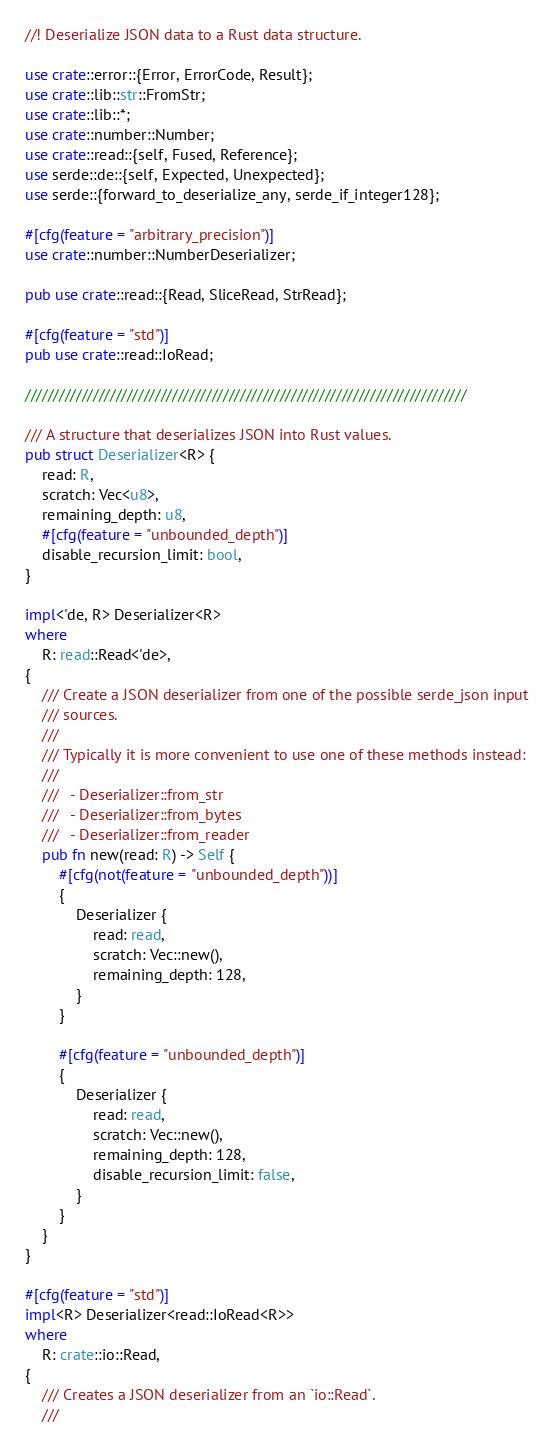<code> <loc_0><loc_0><loc_500><loc_500><_Rust_>//! Deserialize JSON data to a Rust data structure.

use crate::error::{Error, ErrorCode, Result};
use crate::lib::str::FromStr;
use crate::lib::*;
use crate::number::Number;
use crate::read::{self, Fused, Reference};
use serde::de::{self, Expected, Unexpected};
use serde::{forward_to_deserialize_any, serde_if_integer128};

#[cfg(feature = "arbitrary_precision")]
use crate::number::NumberDeserializer;

pub use crate::read::{Read, SliceRead, StrRead};

#[cfg(feature = "std")]
pub use crate::read::IoRead;

//////////////////////////////////////////////////////////////////////////////

/// A structure that deserializes JSON into Rust values.
pub struct Deserializer<R> {
    read: R,
    scratch: Vec<u8>,
    remaining_depth: u8,
    #[cfg(feature = "unbounded_depth")]
    disable_recursion_limit: bool,
}

impl<'de, R> Deserializer<R>
where
    R: read::Read<'de>,
{
    /// Create a JSON deserializer from one of the possible serde_json input
    /// sources.
    ///
    /// Typically it is more convenient to use one of these methods instead:
    ///
    ///   - Deserializer::from_str
    ///   - Deserializer::from_bytes
    ///   - Deserializer::from_reader
    pub fn new(read: R) -> Self {
        #[cfg(not(feature = "unbounded_depth"))]
        {
            Deserializer {
                read: read,
                scratch: Vec::new(),
                remaining_depth: 128,
            }
        }

        #[cfg(feature = "unbounded_depth")]
        {
            Deserializer {
                read: read,
                scratch: Vec::new(),
                remaining_depth: 128,
                disable_recursion_limit: false,
            }
        }
    }
}

#[cfg(feature = "std")]
impl<R> Deserializer<read::IoRead<R>>
where
    R: crate::io::Read,
{
    /// Creates a JSON deserializer from an `io::Read`.
    ///</code> 